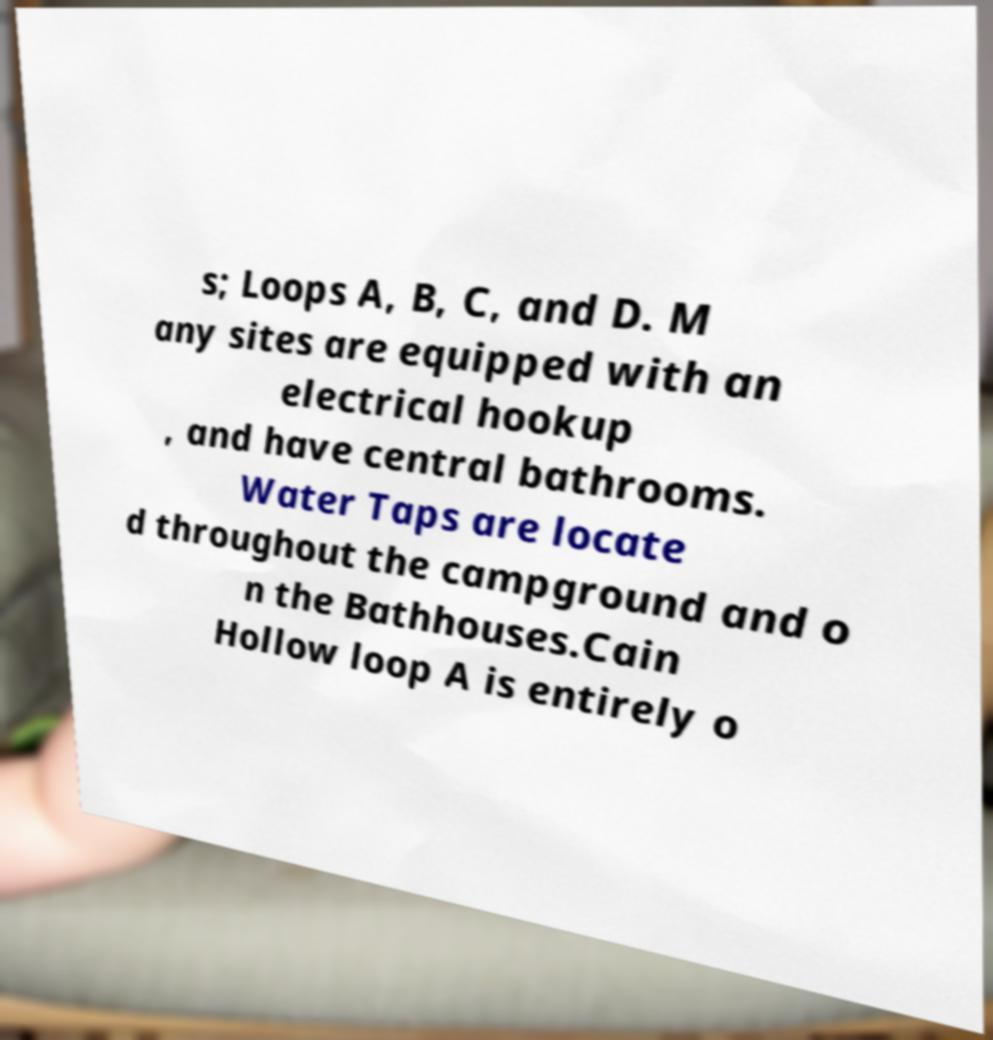Could you extract and type out the text from this image? s; Loops A, B, C, and D. M any sites are equipped with an electrical hookup , and have central bathrooms. Water Taps are locate d throughout the campground and o n the Bathhouses.Cain Hollow loop A is entirely o 